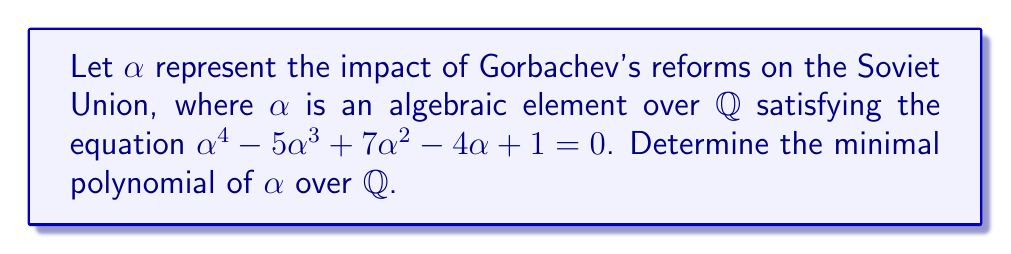Give your solution to this math problem. To find the minimal polynomial of $\alpha$, we need to determine if the given polynomial is irreducible over $\mathbb{Q}$. Let's approach this step-by-step:

1) First, we check if the polynomial has any rational roots using the rational root theorem. The possible rational roots are the factors of the constant term: $\pm 1$.

2) We evaluate the polynomial at $x = 1$ and $x = -1$:
   
   For $x = 1$: $1^4 - 5(1)^3 + 7(1)^2 - 4(1) + 1 = 1 - 5 + 7 - 4 + 1 = 0$
   
   For $x = -1$: $(-1)^4 - 5(-1)^3 + 7(-1)^2 - 4(-1) + 1 = 1 + 5 + 7 + 4 + 1 = 18 \neq 0$

3) We found that 1 is a root of the polynomial. Therefore, $(x-1)$ is a factor.

4) We can divide the original polynomial by $(x-1)$ using polynomial long division:

   $$\frac{x^4 - 5x^3 + 7x^2 - 4x + 1}{x - 1} = x^3 - 4x^2 + 3x - 1$$

5) Now we need to check if $x^3 - 4x^2 + 3x - 1$ is irreducible over $\mathbb{Q}$.

6) We can use Eisenstein's criterion with $p = 3$:
   - 3 doesn't divide the leading coefficient 1
   - 3 divides all other coefficients: -4, 3, -1
   - 3^2 = 9 doesn't divide the constant term -1

7) Therefore, $x^3 - 4x^2 + 3x - 1$ is irreducible over $\mathbb{Q}$.

Thus, the minimal polynomial of $\alpha$ over $\mathbb{Q}$ is $x^3 - 4x^2 + 3x - 1$.
Answer: $x^3 - 4x^2 + 3x - 1$ 